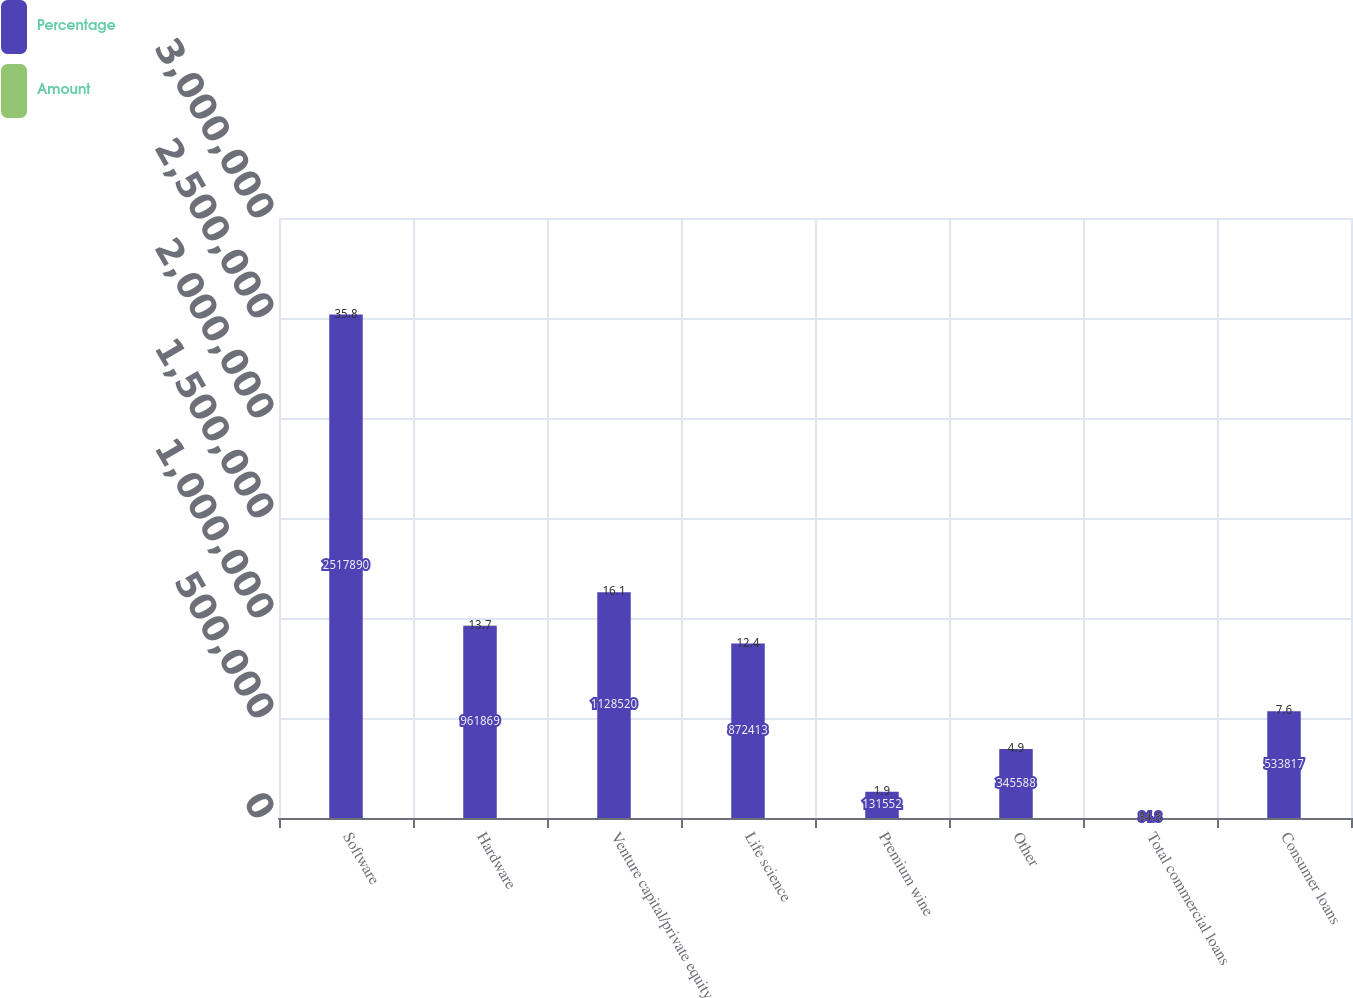Convert chart. <chart><loc_0><loc_0><loc_500><loc_500><stacked_bar_chart><ecel><fcel>Software<fcel>Hardware<fcel>Venture capital/private equity<fcel>Life science<fcel>Premium wine<fcel>Other<fcel>Total commercial loans<fcel>Consumer loans<nl><fcel>Percentage<fcel>2.51789e+06<fcel>961869<fcel>1.12852e+06<fcel>872413<fcel>131552<fcel>345588<fcel>84.8<fcel>533817<nl><fcel>Amount<fcel>35.8<fcel>13.7<fcel>16.1<fcel>12.4<fcel>1.9<fcel>4.9<fcel>84.8<fcel>7.6<nl></chart> 